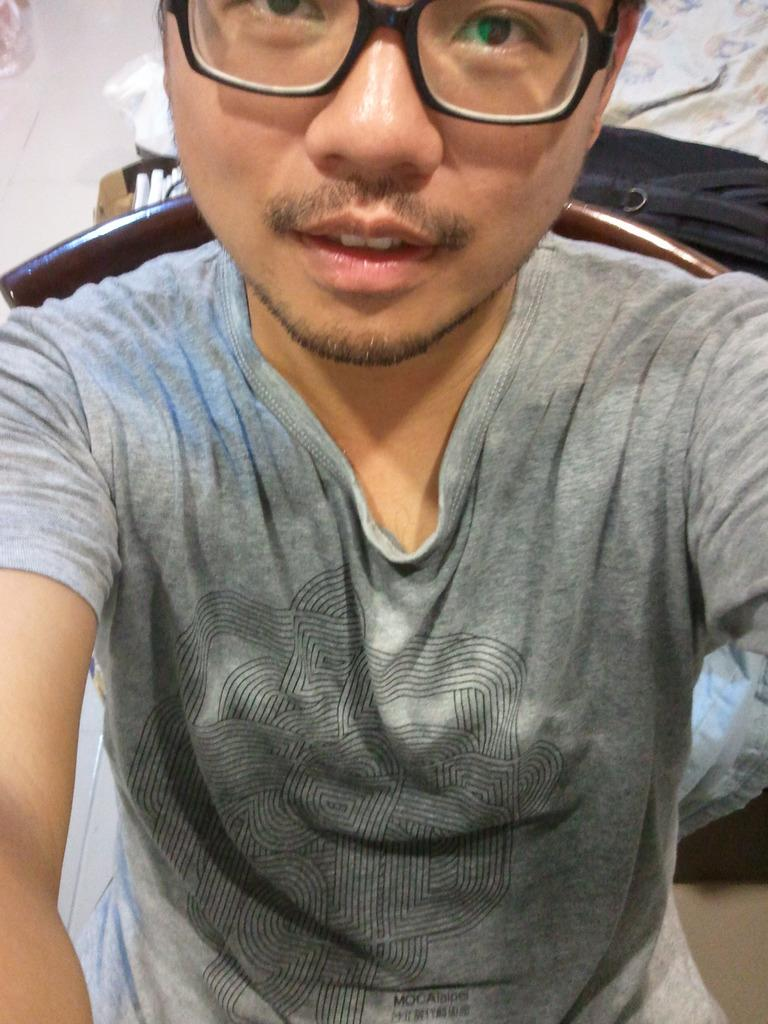Who is present in the image? There is a man in the image. What is the man wearing? The man is wearing a grey T-shirt. Are there any accessories visible on the man? Yes, the man is wearing spectacles. What is located behind the man? There is a chair behind the man. What can be seen in the background of the image? The floor is visible in the background of the image. What type of animal is the man's brother holding in the image? There is no mention of a brother or an animal in the image; it only features a man wearing a grey T-shirt and spectacles, with a chair behind him and a visible floor in the background. 